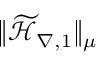<formula> <loc_0><loc_0><loc_500><loc_500>\| \widetilde { \mathcal { H } } _ { \nabla , 1 } \| _ { \mu }</formula> 